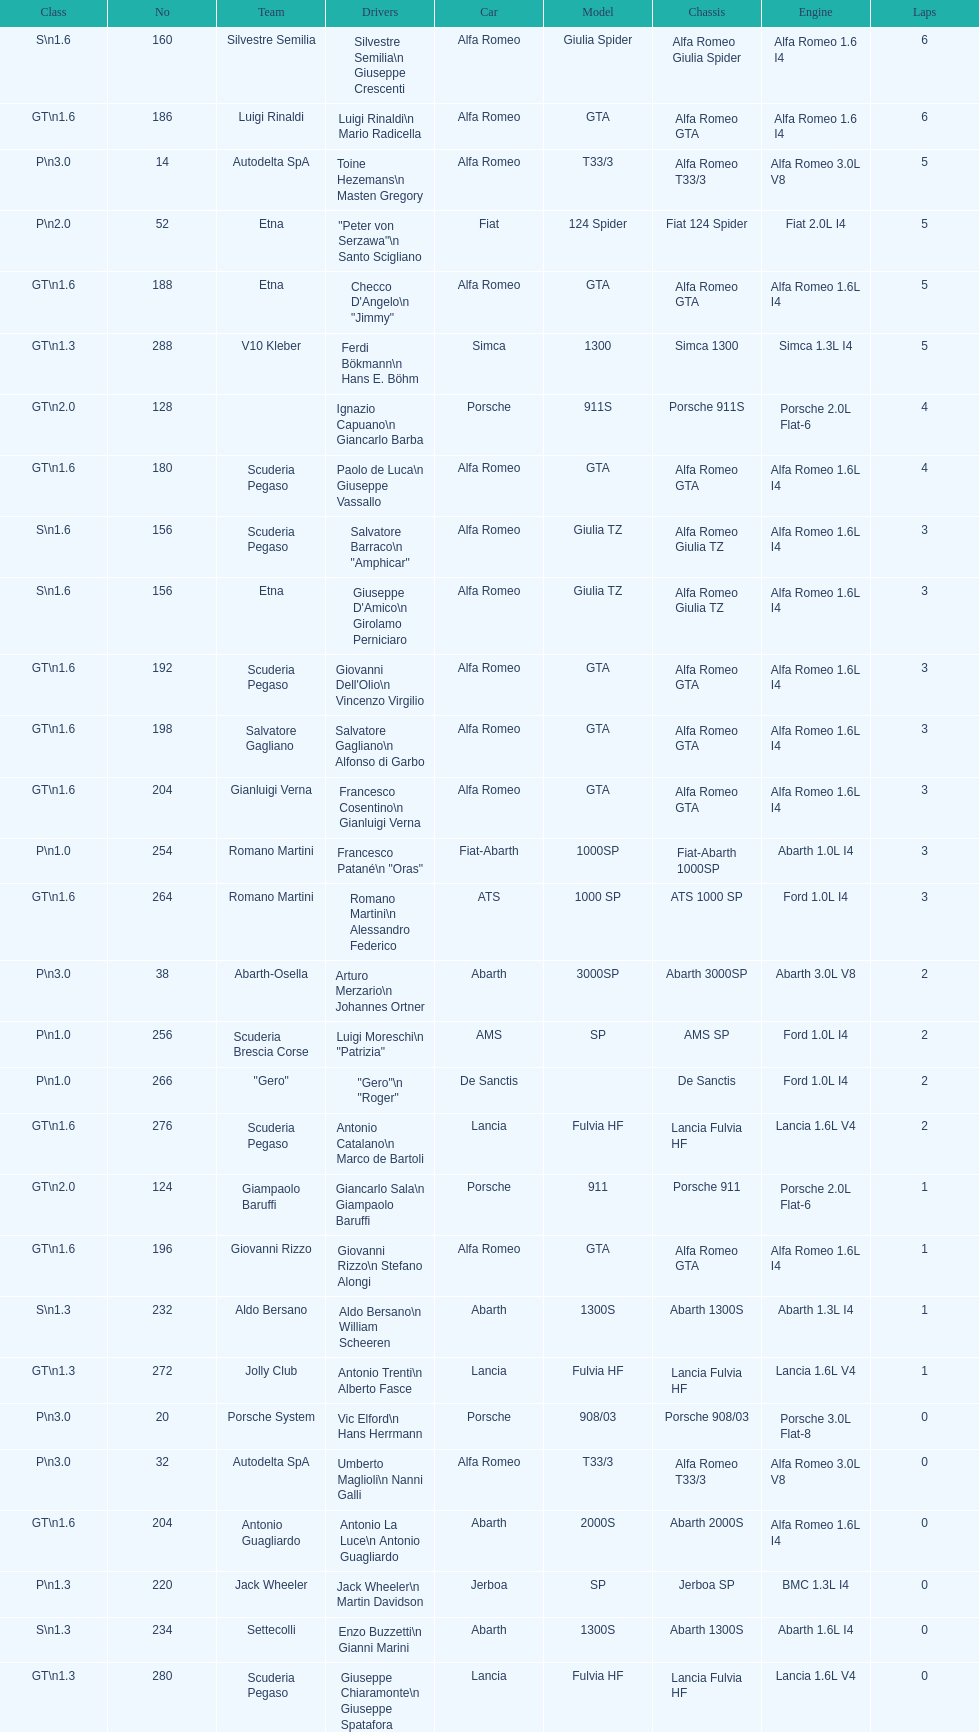Which chassis is in the middle of simca 1300 and alfa romeo gta? Porsche 911S. 